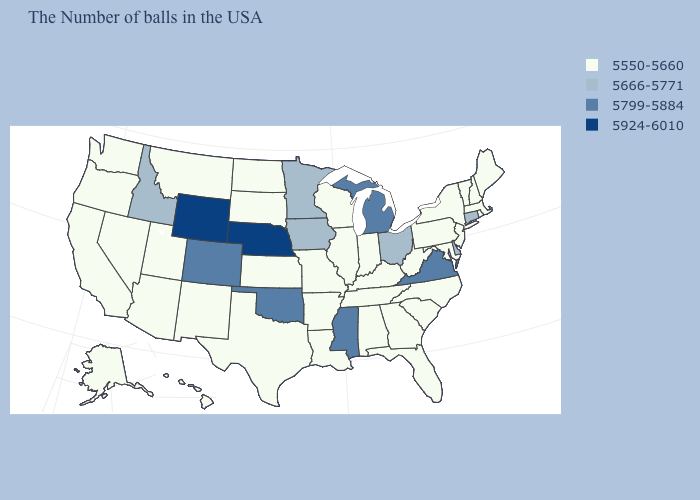Does New Hampshire have a higher value than Texas?
Concise answer only. No. Name the states that have a value in the range 5666-5771?
Quick response, please. Connecticut, Delaware, Ohio, Minnesota, Iowa, Idaho. Is the legend a continuous bar?
Write a very short answer. No. Does Iowa have a lower value than Virginia?
Give a very brief answer. Yes. What is the highest value in the USA?
Keep it brief. 5924-6010. Name the states that have a value in the range 5550-5660?
Quick response, please. Maine, Massachusetts, Rhode Island, New Hampshire, Vermont, New York, New Jersey, Maryland, Pennsylvania, North Carolina, South Carolina, West Virginia, Florida, Georgia, Kentucky, Indiana, Alabama, Tennessee, Wisconsin, Illinois, Louisiana, Missouri, Arkansas, Kansas, Texas, South Dakota, North Dakota, New Mexico, Utah, Montana, Arizona, Nevada, California, Washington, Oregon, Alaska, Hawaii. Name the states that have a value in the range 5550-5660?
Keep it brief. Maine, Massachusetts, Rhode Island, New Hampshire, Vermont, New York, New Jersey, Maryland, Pennsylvania, North Carolina, South Carolina, West Virginia, Florida, Georgia, Kentucky, Indiana, Alabama, Tennessee, Wisconsin, Illinois, Louisiana, Missouri, Arkansas, Kansas, Texas, South Dakota, North Dakota, New Mexico, Utah, Montana, Arizona, Nevada, California, Washington, Oregon, Alaska, Hawaii. Does Alabama have a lower value than Michigan?
Give a very brief answer. Yes. Name the states that have a value in the range 5799-5884?
Quick response, please. Virginia, Michigan, Mississippi, Oklahoma, Colorado. Does Mississippi have the lowest value in the USA?
Give a very brief answer. No. What is the value of Utah?
Answer briefly. 5550-5660. What is the value of Tennessee?
Write a very short answer. 5550-5660. Which states have the lowest value in the USA?
Keep it brief. Maine, Massachusetts, Rhode Island, New Hampshire, Vermont, New York, New Jersey, Maryland, Pennsylvania, North Carolina, South Carolina, West Virginia, Florida, Georgia, Kentucky, Indiana, Alabama, Tennessee, Wisconsin, Illinois, Louisiana, Missouri, Arkansas, Kansas, Texas, South Dakota, North Dakota, New Mexico, Utah, Montana, Arizona, Nevada, California, Washington, Oregon, Alaska, Hawaii. What is the value of New Jersey?
Concise answer only. 5550-5660. Does the map have missing data?
Concise answer only. No. 